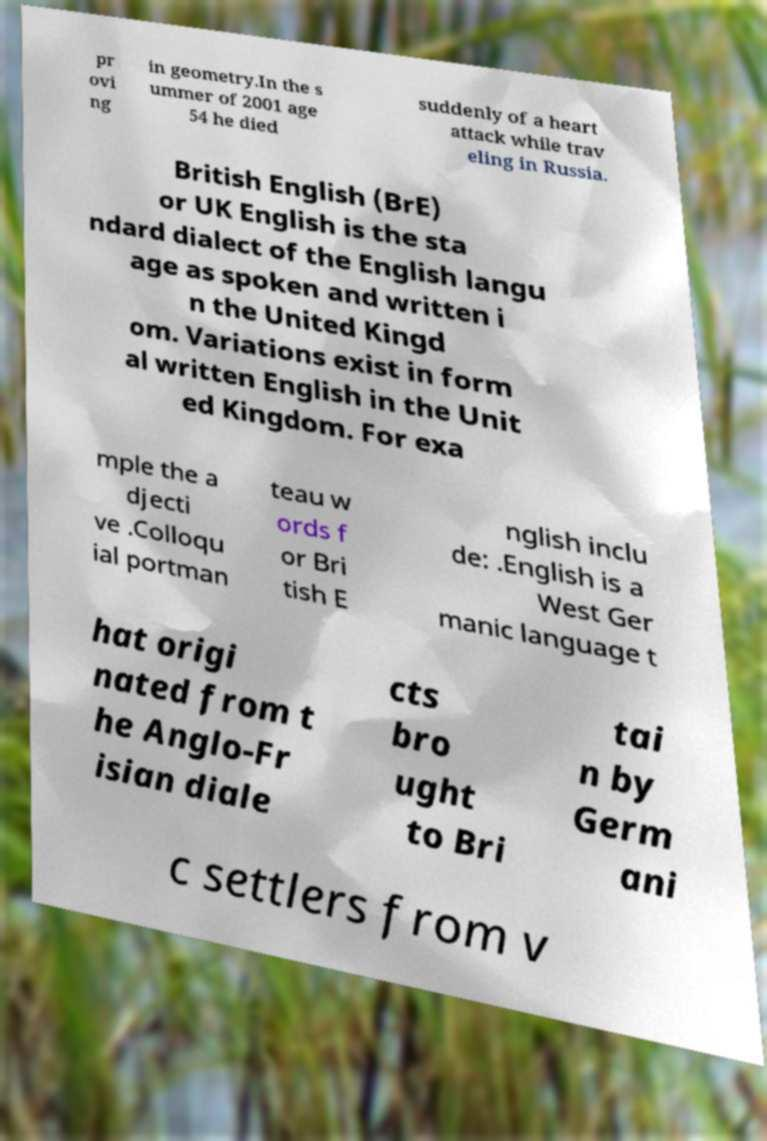Please identify and transcribe the text found in this image. pr ovi ng in geometry.In the s ummer of 2001 age 54 he died suddenly of a heart attack while trav eling in Russia. British English (BrE) or UK English is the sta ndard dialect of the English langu age as spoken and written i n the United Kingd om. Variations exist in form al written English in the Unit ed Kingdom. For exa mple the a djecti ve .Colloqu ial portman teau w ords f or Bri tish E nglish inclu de: .English is a West Ger manic language t hat origi nated from t he Anglo-Fr isian diale cts bro ught to Bri tai n by Germ ani c settlers from v 